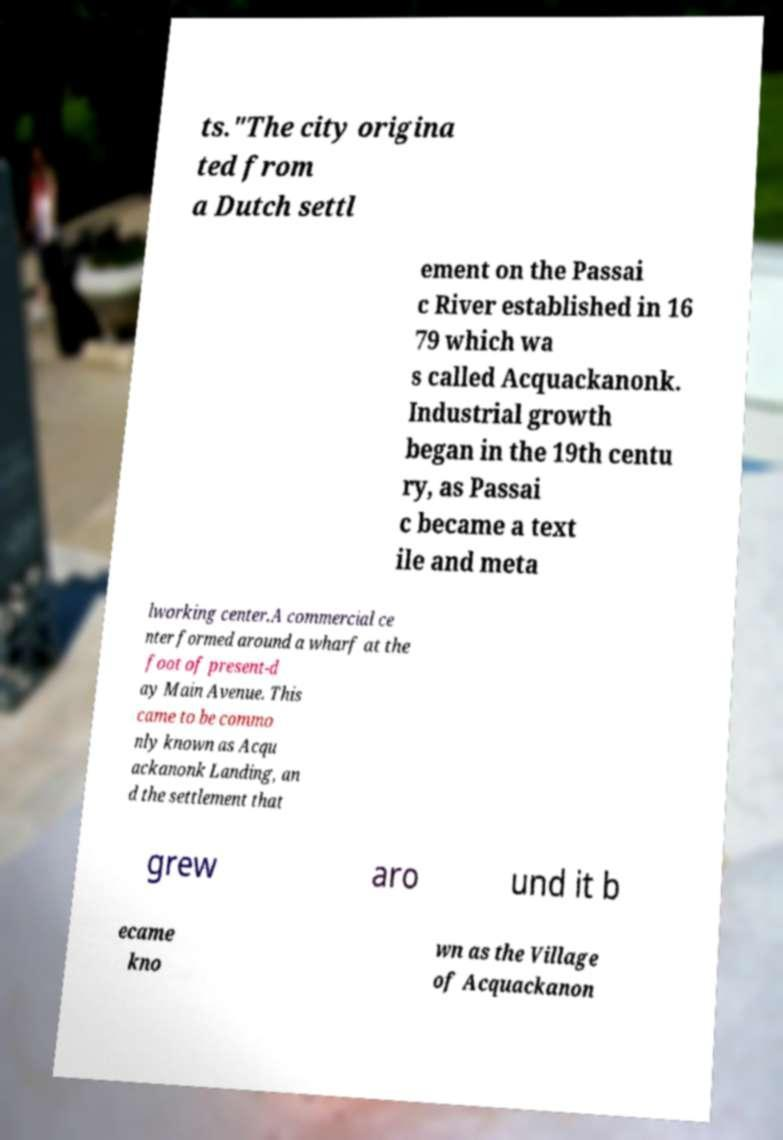For documentation purposes, I need the text within this image transcribed. Could you provide that? ts."The city origina ted from a Dutch settl ement on the Passai c River established in 16 79 which wa s called Acquackanonk. Industrial growth began in the 19th centu ry, as Passai c became a text ile and meta lworking center.A commercial ce nter formed around a wharf at the foot of present-d ay Main Avenue. This came to be commo nly known as Acqu ackanonk Landing, an d the settlement that grew aro und it b ecame kno wn as the Village of Acquackanon 